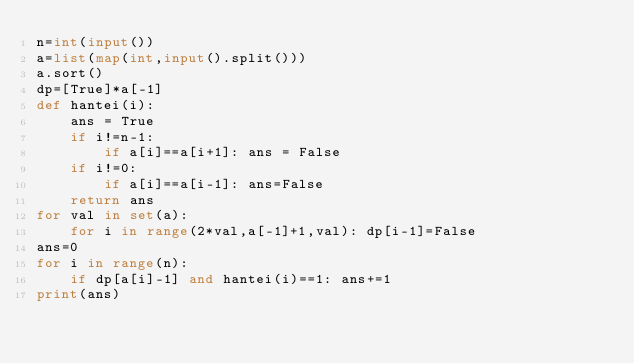Convert code to text. <code><loc_0><loc_0><loc_500><loc_500><_Python_>n=int(input())
a=list(map(int,input().split()))
a.sort()
dp=[True]*a[-1]
def hantei(i):
    ans = True
    if i!=n-1:
        if a[i]==a[i+1]: ans = False
    if i!=0:
        if a[i]==a[i-1]: ans=False
    return ans
for val in set(a):
    for i in range(2*val,a[-1]+1,val): dp[i-1]=False
ans=0
for i in range(n):
    if dp[a[i]-1] and hantei(i)==1: ans+=1
print(ans)</code> 